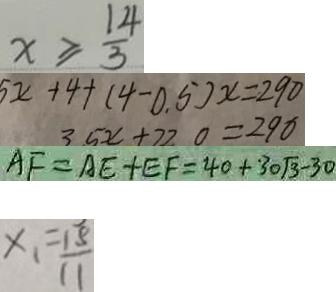<formula> <loc_0><loc_0><loc_500><loc_500>x \geq \frac { 1 4 } { 3 } 
 5 x + 4 + ( 4 - 0 . 5 ) x = 2 9 0 
 A F = A E + E F = 4 0 + 3 0 \sqrt { 3 } - 3 0 
 x _ { 1 } = \frac { 1 5 } { 1 1 }</formula> 